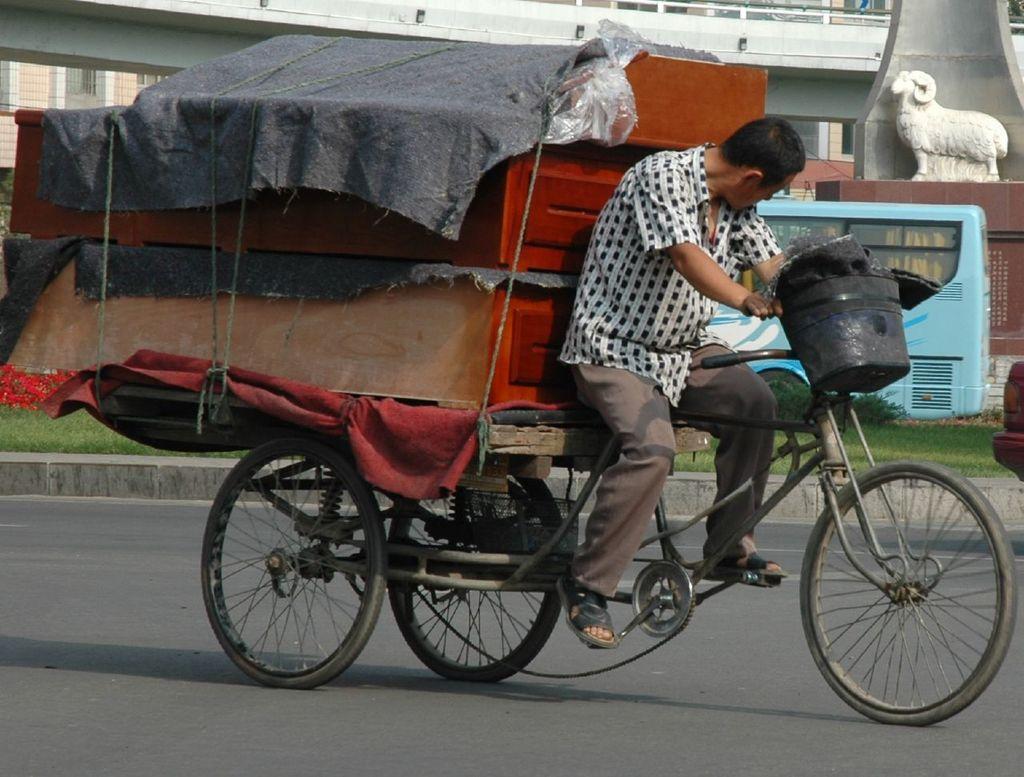Can you describe this image briefly? In this picture there is a man in the center of the image on a tricycle, there is a statue of sheep in the top right side of the image and there is a bus and a bridge in the background area of the image. 